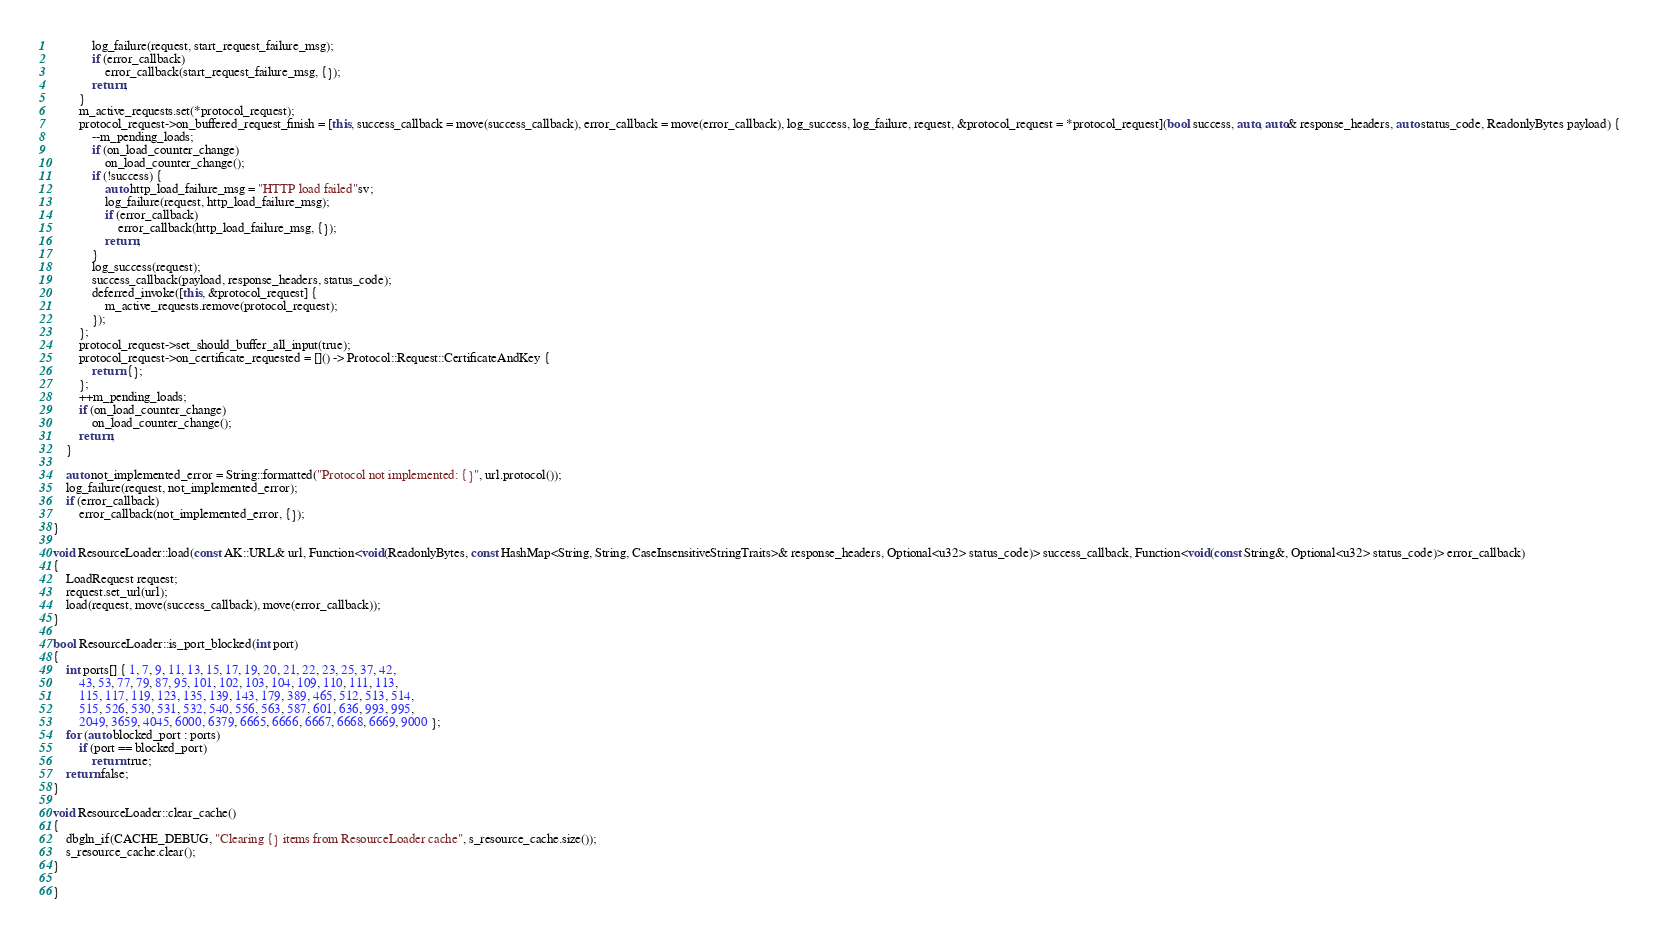<code> <loc_0><loc_0><loc_500><loc_500><_C++_>            log_failure(request, start_request_failure_msg);
            if (error_callback)
                error_callback(start_request_failure_msg, {});
            return;
        }
        m_active_requests.set(*protocol_request);
        protocol_request->on_buffered_request_finish = [this, success_callback = move(success_callback), error_callback = move(error_callback), log_success, log_failure, request, &protocol_request = *protocol_request](bool success, auto, auto& response_headers, auto status_code, ReadonlyBytes payload) {
            --m_pending_loads;
            if (on_load_counter_change)
                on_load_counter_change();
            if (!success) {
                auto http_load_failure_msg = "HTTP load failed"sv;
                log_failure(request, http_load_failure_msg);
                if (error_callback)
                    error_callback(http_load_failure_msg, {});
                return;
            }
            log_success(request);
            success_callback(payload, response_headers, status_code);
            deferred_invoke([this, &protocol_request] {
                m_active_requests.remove(protocol_request);
            });
        };
        protocol_request->set_should_buffer_all_input(true);
        protocol_request->on_certificate_requested = []() -> Protocol::Request::CertificateAndKey {
            return {};
        };
        ++m_pending_loads;
        if (on_load_counter_change)
            on_load_counter_change();
        return;
    }

    auto not_implemented_error = String::formatted("Protocol not implemented: {}", url.protocol());
    log_failure(request, not_implemented_error);
    if (error_callback)
        error_callback(not_implemented_error, {});
}

void ResourceLoader::load(const AK::URL& url, Function<void(ReadonlyBytes, const HashMap<String, String, CaseInsensitiveStringTraits>& response_headers, Optional<u32> status_code)> success_callback, Function<void(const String&, Optional<u32> status_code)> error_callback)
{
    LoadRequest request;
    request.set_url(url);
    load(request, move(success_callback), move(error_callback));
}

bool ResourceLoader::is_port_blocked(int port)
{
    int ports[] { 1, 7, 9, 11, 13, 15, 17, 19, 20, 21, 22, 23, 25, 37, 42,
        43, 53, 77, 79, 87, 95, 101, 102, 103, 104, 109, 110, 111, 113,
        115, 117, 119, 123, 135, 139, 143, 179, 389, 465, 512, 513, 514,
        515, 526, 530, 531, 532, 540, 556, 563, 587, 601, 636, 993, 995,
        2049, 3659, 4045, 6000, 6379, 6665, 6666, 6667, 6668, 6669, 9000 };
    for (auto blocked_port : ports)
        if (port == blocked_port)
            return true;
    return false;
}

void ResourceLoader::clear_cache()
{
    dbgln_if(CACHE_DEBUG, "Clearing {} items from ResourceLoader cache", s_resource_cache.size());
    s_resource_cache.clear();
}

}
</code> 